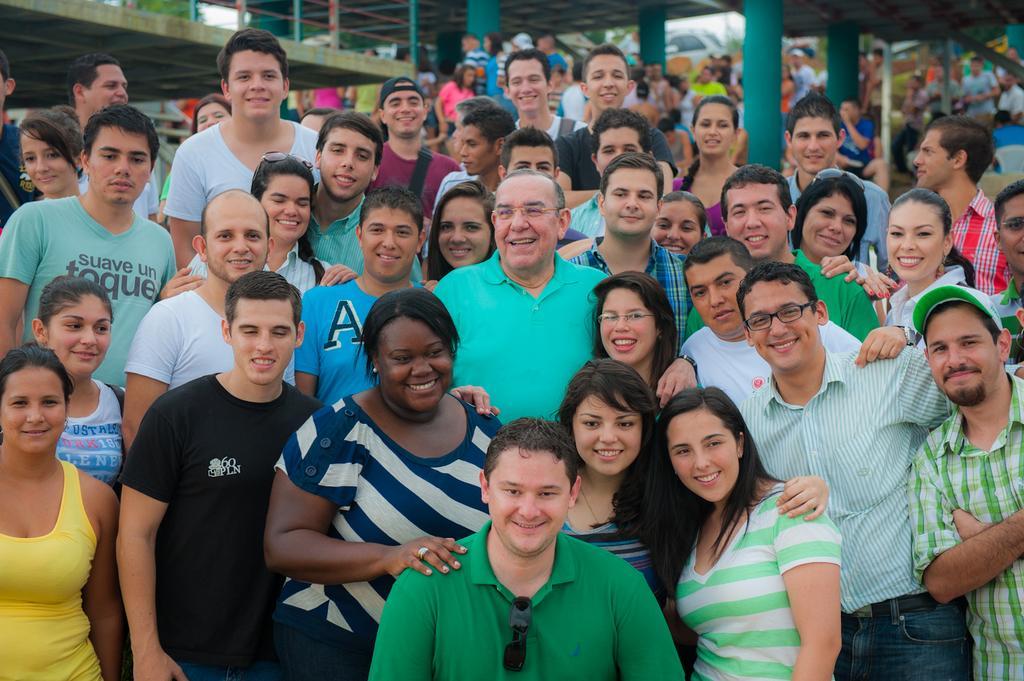Could you give a brief overview of what you see in this image? In the picture I can see a group of people are standing and smiling. In the background I can see green color poles, fence and some other objects. The background of the image is blurred. 